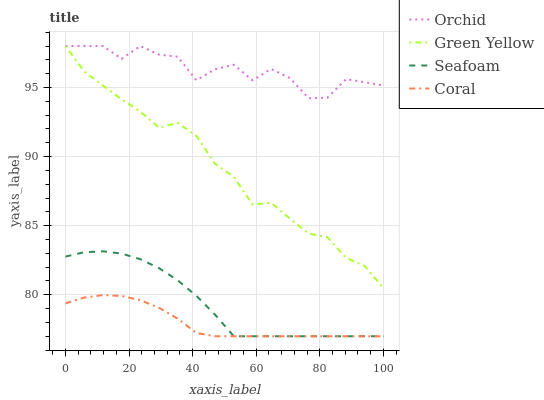Does Coral have the minimum area under the curve?
Answer yes or no. Yes. Does Orchid have the maximum area under the curve?
Answer yes or no. Yes. Does Green Yellow have the minimum area under the curve?
Answer yes or no. No. Does Green Yellow have the maximum area under the curve?
Answer yes or no. No. Is Coral the smoothest?
Answer yes or no. Yes. Is Orchid the roughest?
Answer yes or no. Yes. Is Green Yellow the smoothest?
Answer yes or no. No. Is Green Yellow the roughest?
Answer yes or no. No. Does Coral have the lowest value?
Answer yes or no. Yes. Does Green Yellow have the lowest value?
Answer yes or no. No. Does Orchid have the highest value?
Answer yes or no. Yes. Does Seafoam have the highest value?
Answer yes or no. No. Is Coral less than Orchid?
Answer yes or no. Yes. Is Orchid greater than Coral?
Answer yes or no. Yes. Does Seafoam intersect Coral?
Answer yes or no. Yes. Is Seafoam less than Coral?
Answer yes or no. No. Is Seafoam greater than Coral?
Answer yes or no. No. Does Coral intersect Orchid?
Answer yes or no. No. 